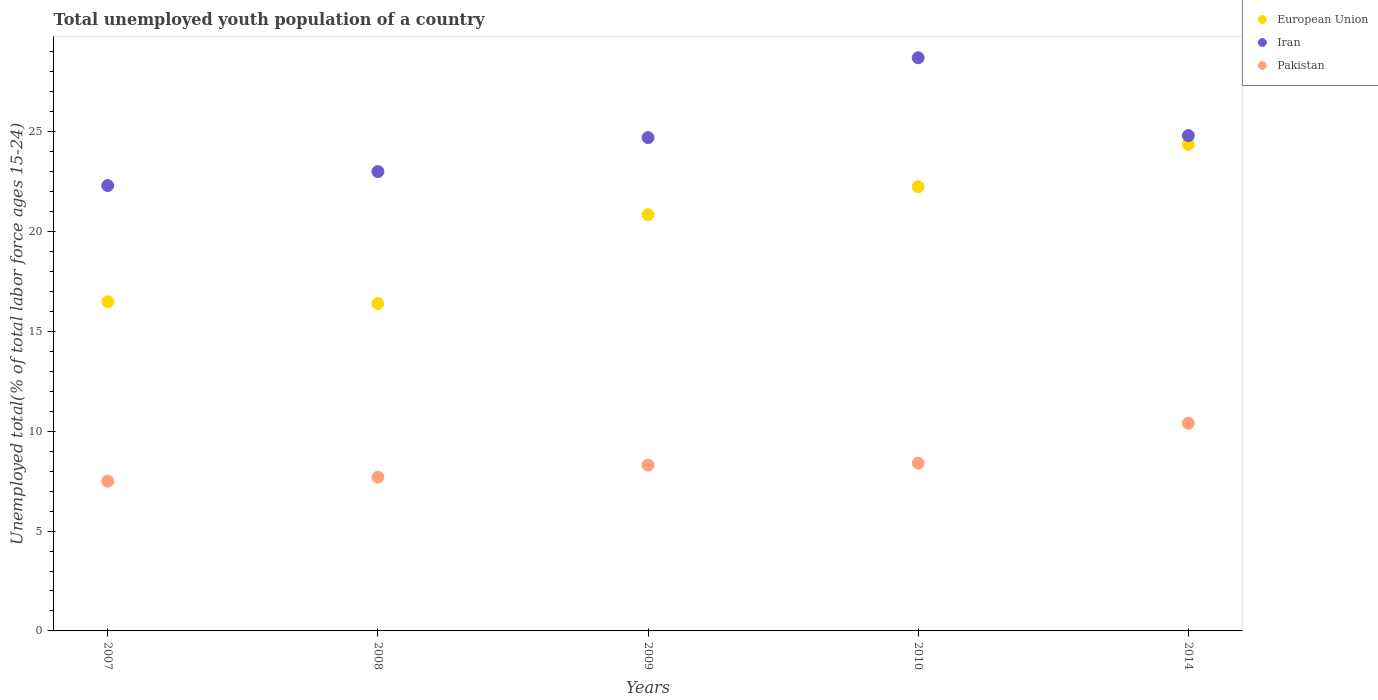How many different coloured dotlines are there?
Your answer should be compact. 3. Is the number of dotlines equal to the number of legend labels?
Your response must be concise. Yes. What is the percentage of total unemployed youth population of a country in European Union in 2009?
Offer a very short reply. 20.84. Across all years, what is the maximum percentage of total unemployed youth population of a country in Pakistan?
Provide a short and direct response. 10.4. Across all years, what is the minimum percentage of total unemployed youth population of a country in Pakistan?
Your response must be concise. 7.5. In which year was the percentage of total unemployed youth population of a country in Iran minimum?
Your response must be concise. 2007. What is the total percentage of total unemployed youth population of a country in Pakistan in the graph?
Offer a terse response. 42.3. What is the difference between the percentage of total unemployed youth population of a country in Pakistan in 2007 and that in 2010?
Give a very brief answer. -0.9. What is the difference between the percentage of total unemployed youth population of a country in European Union in 2008 and the percentage of total unemployed youth population of a country in Pakistan in 2007?
Provide a short and direct response. 8.89. What is the average percentage of total unemployed youth population of a country in European Union per year?
Ensure brevity in your answer.  20.06. In the year 2014, what is the difference between the percentage of total unemployed youth population of a country in European Union and percentage of total unemployed youth population of a country in Pakistan?
Give a very brief answer. 13.96. In how many years, is the percentage of total unemployed youth population of a country in Pakistan greater than 6 %?
Provide a succinct answer. 5. What is the ratio of the percentage of total unemployed youth population of a country in Iran in 2009 to that in 2014?
Your answer should be compact. 1. Is the difference between the percentage of total unemployed youth population of a country in European Union in 2007 and 2009 greater than the difference between the percentage of total unemployed youth population of a country in Pakistan in 2007 and 2009?
Your response must be concise. No. What is the difference between the highest and the second highest percentage of total unemployed youth population of a country in European Union?
Your answer should be compact. 2.12. What is the difference between the highest and the lowest percentage of total unemployed youth population of a country in European Union?
Provide a short and direct response. 7.97. In how many years, is the percentage of total unemployed youth population of a country in European Union greater than the average percentage of total unemployed youth population of a country in European Union taken over all years?
Ensure brevity in your answer.  3. Is it the case that in every year, the sum of the percentage of total unemployed youth population of a country in Iran and percentage of total unemployed youth population of a country in Pakistan  is greater than the percentage of total unemployed youth population of a country in European Union?
Give a very brief answer. Yes. Is the percentage of total unemployed youth population of a country in Iran strictly greater than the percentage of total unemployed youth population of a country in European Union over the years?
Your response must be concise. Yes. Is the percentage of total unemployed youth population of a country in European Union strictly less than the percentage of total unemployed youth population of a country in Iran over the years?
Your response must be concise. Yes. How many dotlines are there?
Offer a terse response. 3. How many years are there in the graph?
Give a very brief answer. 5. Are the values on the major ticks of Y-axis written in scientific E-notation?
Your answer should be very brief. No. How many legend labels are there?
Offer a very short reply. 3. How are the legend labels stacked?
Provide a succinct answer. Vertical. What is the title of the graph?
Your answer should be compact. Total unemployed youth population of a country. What is the label or title of the Y-axis?
Keep it short and to the point. Unemployed total(% of total labor force ages 15-24). What is the Unemployed total(% of total labor force ages 15-24) of European Union in 2007?
Make the answer very short. 16.49. What is the Unemployed total(% of total labor force ages 15-24) in Iran in 2007?
Make the answer very short. 22.3. What is the Unemployed total(% of total labor force ages 15-24) in Pakistan in 2007?
Your answer should be compact. 7.5. What is the Unemployed total(% of total labor force ages 15-24) in European Union in 2008?
Make the answer very short. 16.39. What is the Unemployed total(% of total labor force ages 15-24) of Pakistan in 2008?
Provide a short and direct response. 7.7. What is the Unemployed total(% of total labor force ages 15-24) in European Union in 2009?
Give a very brief answer. 20.84. What is the Unemployed total(% of total labor force ages 15-24) in Iran in 2009?
Make the answer very short. 24.7. What is the Unemployed total(% of total labor force ages 15-24) of Pakistan in 2009?
Your answer should be very brief. 8.3. What is the Unemployed total(% of total labor force ages 15-24) of European Union in 2010?
Provide a short and direct response. 22.24. What is the Unemployed total(% of total labor force ages 15-24) in Iran in 2010?
Your answer should be very brief. 28.7. What is the Unemployed total(% of total labor force ages 15-24) of Pakistan in 2010?
Provide a succinct answer. 8.4. What is the Unemployed total(% of total labor force ages 15-24) of European Union in 2014?
Offer a very short reply. 24.36. What is the Unemployed total(% of total labor force ages 15-24) in Iran in 2014?
Provide a short and direct response. 24.8. What is the Unemployed total(% of total labor force ages 15-24) in Pakistan in 2014?
Give a very brief answer. 10.4. Across all years, what is the maximum Unemployed total(% of total labor force ages 15-24) of European Union?
Your answer should be very brief. 24.36. Across all years, what is the maximum Unemployed total(% of total labor force ages 15-24) in Iran?
Provide a succinct answer. 28.7. Across all years, what is the maximum Unemployed total(% of total labor force ages 15-24) of Pakistan?
Offer a terse response. 10.4. Across all years, what is the minimum Unemployed total(% of total labor force ages 15-24) in European Union?
Give a very brief answer. 16.39. Across all years, what is the minimum Unemployed total(% of total labor force ages 15-24) in Iran?
Ensure brevity in your answer.  22.3. What is the total Unemployed total(% of total labor force ages 15-24) in European Union in the graph?
Offer a terse response. 100.32. What is the total Unemployed total(% of total labor force ages 15-24) in Iran in the graph?
Offer a very short reply. 123.5. What is the total Unemployed total(% of total labor force ages 15-24) of Pakistan in the graph?
Offer a very short reply. 42.3. What is the difference between the Unemployed total(% of total labor force ages 15-24) of European Union in 2007 and that in 2008?
Offer a terse response. 0.1. What is the difference between the Unemployed total(% of total labor force ages 15-24) of Iran in 2007 and that in 2008?
Offer a terse response. -0.7. What is the difference between the Unemployed total(% of total labor force ages 15-24) in European Union in 2007 and that in 2009?
Keep it short and to the point. -4.35. What is the difference between the Unemployed total(% of total labor force ages 15-24) in Iran in 2007 and that in 2009?
Offer a terse response. -2.4. What is the difference between the Unemployed total(% of total labor force ages 15-24) of Pakistan in 2007 and that in 2009?
Provide a succinct answer. -0.8. What is the difference between the Unemployed total(% of total labor force ages 15-24) in European Union in 2007 and that in 2010?
Make the answer very short. -5.75. What is the difference between the Unemployed total(% of total labor force ages 15-24) of Iran in 2007 and that in 2010?
Offer a terse response. -6.4. What is the difference between the Unemployed total(% of total labor force ages 15-24) in European Union in 2007 and that in 2014?
Give a very brief answer. -7.88. What is the difference between the Unemployed total(% of total labor force ages 15-24) in Iran in 2007 and that in 2014?
Keep it short and to the point. -2.5. What is the difference between the Unemployed total(% of total labor force ages 15-24) in Pakistan in 2007 and that in 2014?
Your answer should be very brief. -2.9. What is the difference between the Unemployed total(% of total labor force ages 15-24) in European Union in 2008 and that in 2009?
Provide a short and direct response. -4.45. What is the difference between the Unemployed total(% of total labor force ages 15-24) of Iran in 2008 and that in 2009?
Ensure brevity in your answer.  -1.7. What is the difference between the Unemployed total(% of total labor force ages 15-24) in European Union in 2008 and that in 2010?
Offer a terse response. -5.85. What is the difference between the Unemployed total(% of total labor force ages 15-24) of Pakistan in 2008 and that in 2010?
Ensure brevity in your answer.  -0.7. What is the difference between the Unemployed total(% of total labor force ages 15-24) in European Union in 2008 and that in 2014?
Provide a short and direct response. -7.97. What is the difference between the Unemployed total(% of total labor force ages 15-24) of European Union in 2009 and that in 2010?
Give a very brief answer. -1.4. What is the difference between the Unemployed total(% of total labor force ages 15-24) of Pakistan in 2009 and that in 2010?
Keep it short and to the point. -0.1. What is the difference between the Unemployed total(% of total labor force ages 15-24) in European Union in 2009 and that in 2014?
Provide a short and direct response. -3.52. What is the difference between the Unemployed total(% of total labor force ages 15-24) of Iran in 2009 and that in 2014?
Offer a terse response. -0.1. What is the difference between the Unemployed total(% of total labor force ages 15-24) in European Union in 2010 and that in 2014?
Ensure brevity in your answer.  -2.12. What is the difference between the Unemployed total(% of total labor force ages 15-24) in Pakistan in 2010 and that in 2014?
Give a very brief answer. -2. What is the difference between the Unemployed total(% of total labor force ages 15-24) in European Union in 2007 and the Unemployed total(% of total labor force ages 15-24) in Iran in 2008?
Keep it short and to the point. -6.51. What is the difference between the Unemployed total(% of total labor force ages 15-24) of European Union in 2007 and the Unemployed total(% of total labor force ages 15-24) of Pakistan in 2008?
Provide a succinct answer. 8.79. What is the difference between the Unemployed total(% of total labor force ages 15-24) in Iran in 2007 and the Unemployed total(% of total labor force ages 15-24) in Pakistan in 2008?
Your response must be concise. 14.6. What is the difference between the Unemployed total(% of total labor force ages 15-24) of European Union in 2007 and the Unemployed total(% of total labor force ages 15-24) of Iran in 2009?
Make the answer very short. -8.21. What is the difference between the Unemployed total(% of total labor force ages 15-24) of European Union in 2007 and the Unemployed total(% of total labor force ages 15-24) of Pakistan in 2009?
Provide a succinct answer. 8.19. What is the difference between the Unemployed total(% of total labor force ages 15-24) in Iran in 2007 and the Unemployed total(% of total labor force ages 15-24) in Pakistan in 2009?
Provide a succinct answer. 14. What is the difference between the Unemployed total(% of total labor force ages 15-24) in European Union in 2007 and the Unemployed total(% of total labor force ages 15-24) in Iran in 2010?
Your answer should be very brief. -12.21. What is the difference between the Unemployed total(% of total labor force ages 15-24) in European Union in 2007 and the Unemployed total(% of total labor force ages 15-24) in Pakistan in 2010?
Ensure brevity in your answer.  8.09. What is the difference between the Unemployed total(% of total labor force ages 15-24) of Iran in 2007 and the Unemployed total(% of total labor force ages 15-24) of Pakistan in 2010?
Provide a succinct answer. 13.9. What is the difference between the Unemployed total(% of total labor force ages 15-24) of European Union in 2007 and the Unemployed total(% of total labor force ages 15-24) of Iran in 2014?
Offer a very short reply. -8.31. What is the difference between the Unemployed total(% of total labor force ages 15-24) in European Union in 2007 and the Unemployed total(% of total labor force ages 15-24) in Pakistan in 2014?
Ensure brevity in your answer.  6.09. What is the difference between the Unemployed total(% of total labor force ages 15-24) of European Union in 2008 and the Unemployed total(% of total labor force ages 15-24) of Iran in 2009?
Provide a short and direct response. -8.31. What is the difference between the Unemployed total(% of total labor force ages 15-24) of European Union in 2008 and the Unemployed total(% of total labor force ages 15-24) of Pakistan in 2009?
Your answer should be compact. 8.09. What is the difference between the Unemployed total(% of total labor force ages 15-24) of European Union in 2008 and the Unemployed total(% of total labor force ages 15-24) of Iran in 2010?
Your response must be concise. -12.31. What is the difference between the Unemployed total(% of total labor force ages 15-24) in European Union in 2008 and the Unemployed total(% of total labor force ages 15-24) in Pakistan in 2010?
Provide a short and direct response. 7.99. What is the difference between the Unemployed total(% of total labor force ages 15-24) of European Union in 2008 and the Unemployed total(% of total labor force ages 15-24) of Iran in 2014?
Your response must be concise. -8.41. What is the difference between the Unemployed total(% of total labor force ages 15-24) of European Union in 2008 and the Unemployed total(% of total labor force ages 15-24) of Pakistan in 2014?
Provide a short and direct response. 5.99. What is the difference between the Unemployed total(% of total labor force ages 15-24) in European Union in 2009 and the Unemployed total(% of total labor force ages 15-24) in Iran in 2010?
Provide a short and direct response. -7.86. What is the difference between the Unemployed total(% of total labor force ages 15-24) of European Union in 2009 and the Unemployed total(% of total labor force ages 15-24) of Pakistan in 2010?
Your answer should be compact. 12.44. What is the difference between the Unemployed total(% of total labor force ages 15-24) in European Union in 2009 and the Unemployed total(% of total labor force ages 15-24) in Iran in 2014?
Ensure brevity in your answer.  -3.96. What is the difference between the Unemployed total(% of total labor force ages 15-24) in European Union in 2009 and the Unemployed total(% of total labor force ages 15-24) in Pakistan in 2014?
Ensure brevity in your answer.  10.44. What is the difference between the Unemployed total(% of total labor force ages 15-24) of European Union in 2010 and the Unemployed total(% of total labor force ages 15-24) of Iran in 2014?
Keep it short and to the point. -2.56. What is the difference between the Unemployed total(% of total labor force ages 15-24) in European Union in 2010 and the Unemployed total(% of total labor force ages 15-24) in Pakistan in 2014?
Keep it short and to the point. 11.84. What is the average Unemployed total(% of total labor force ages 15-24) in European Union per year?
Provide a succinct answer. 20.06. What is the average Unemployed total(% of total labor force ages 15-24) in Iran per year?
Your answer should be very brief. 24.7. What is the average Unemployed total(% of total labor force ages 15-24) in Pakistan per year?
Provide a short and direct response. 8.46. In the year 2007, what is the difference between the Unemployed total(% of total labor force ages 15-24) of European Union and Unemployed total(% of total labor force ages 15-24) of Iran?
Offer a terse response. -5.81. In the year 2007, what is the difference between the Unemployed total(% of total labor force ages 15-24) in European Union and Unemployed total(% of total labor force ages 15-24) in Pakistan?
Make the answer very short. 8.99. In the year 2007, what is the difference between the Unemployed total(% of total labor force ages 15-24) of Iran and Unemployed total(% of total labor force ages 15-24) of Pakistan?
Your response must be concise. 14.8. In the year 2008, what is the difference between the Unemployed total(% of total labor force ages 15-24) in European Union and Unemployed total(% of total labor force ages 15-24) in Iran?
Make the answer very short. -6.61. In the year 2008, what is the difference between the Unemployed total(% of total labor force ages 15-24) in European Union and Unemployed total(% of total labor force ages 15-24) in Pakistan?
Your response must be concise. 8.69. In the year 2008, what is the difference between the Unemployed total(% of total labor force ages 15-24) in Iran and Unemployed total(% of total labor force ages 15-24) in Pakistan?
Your answer should be compact. 15.3. In the year 2009, what is the difference between the Unemployed total(% of total labor force ages 15-24) in European Union and Unemployed total(% of total labor force ages 15-24) in Iran?
Provide a short and direct response. -3.86. In the year 2009, what is the difference between the Unemployed total(% of total labor force ages 15-24) in European Union and Unemployed total(% of total labor force ages 15-24) in Pakistan?
Ensure brevity in your answer.  12.54. In the year 2009, what is the difference between the Unemployed total(% of total labor force ages 15-24) in Iran and Unemployed total(% of total labor force ages 15-24) in Pakistan?
Ensure brevity in your answer.  16.4. In the year 2010, what is the difference between the Unemployed total(% of total labor force ages 15-24) in European Union and Unemployed total(% of total labor force ages 15-24) in Iran?
Offer a terse response. -6.46. In the year 2010, what is the difference between the Unemployed total(% of total labor force ages 15-24) in European Union and Unemployed total(% of total labor force ages 15-24) in Pakistan?
Give a very brief answer. 13.84. In the year 2010, what is the difference between the Unemployed total(% of total labor force ages 15-24) in Iran and Unemployed total(% of total labor force ages 15-24) in Pakistan?
Provide a succinct answer. 20.3. In the year 2014, what is the difference between the Unemployed total(% of total labor force ages 15-24) in European Union and Unemployed total(% of total labor force ages 15-24) in Iran?
Make the answer very short. -0.44. In the year 2014, what is the difference between the Unemployed total(% of total labor force ages 15-24) in European Union and Unemployed total(% of total labor force ages 15-24) in Pakistan?
Provide a short and direct response. 13.96. In the year 2014, what is the difference between the Unemployed total(% of total labor force ages 15-24) in Iran and Unemployed total(% of total labor force ages 15-24) in Pakistan?
Your answer should be compact. 14.4. What is the ratio of the Unemployed total(% of total labor force ages 15-24) in Iran in 2007 to that in 2008?
Your answer should be very brief. 0.97. What is the ratio of the Unemployed total(% of total labor force ages 15-24) in Pakistan in 2007 to that in 2008?
Provide a short and direct response. 0.97. What is the ratio of the Unemployed total(% of total labor force ages 15-24) in European Union in 2007 to that in 2009?
Provide a succinct answer. 0.79. What is the ratio of the Unemployed total(% of total labor force ages 15-24) of Iran in 2007 to that in 2009?
Ensure brevity in your answer.  0.9. What is the ratio of the Unemployed total(% of total labor force ages 15-24) of Pakistan in 2007 to that in 2009?
Your answer should be compact. 0.9. What is the ratio of the Unemployed total(% of total labor force ages 15-24) in European Union in 2007 to that in 2010?
Keep it short and to the point. 0.74. What is the ratio of the Unemployed total(% of total labor force ages 15-24) of Iran in 2007 to that in 2010?
Give a very brief answer. 0.78. What is the ratio of the Unemployed total(% of total labor force ages 15-24) of Pakistan in 2007 to that in 2010?
Provide a succinct answer. 0.89. What is the ratio of the Unemployed total(% of total labor force ages 15-24) of European Union in 2007 to that in 2014?
Give a very brief answer. 0.68. What is the ratio of the Unemployed total(% of total labor force ages 15-24) of Iran in 2007 to that in 2014?
Offer a very short reply. 0.9. What is the ratio of the Unemployed total(% of total labor force ages 15-24) in Pakistan in 2007 to that in 2014?
Your response must be concise. 0.72. What is the ratio of the Unemployed total(% of total labor force ages 15-24) in European Union in 2008 to that in 2009?
Keep it short and to the point. 0.79. What is the ratio of the Unemployed total(% of total labor force ages 15-24) of Iran in 2008 to that in 2009?
Keep it short and to the point. 0.93. What is the ratio of the Unemployed total(% of total labor force ages 15-24) in Pakistan in 2008 to that in 2009?
Keep it short and to the point. 0.93. What is the ratio of the Unemployed total(% of total labor force ages 15-24) in European Union in 2008 to that in 2010?
Offer a terse response. 0.74. What is the ratio of the Unemployed total(% of total labor force ages 15-24) of Iran in 2008 to that in 2010?
Make the answer very short. 0.8. What is the ratio of the Unemployed total(% of total labor force ages 15-24) in Pakistan in 2008 to that in 2010?
Ensure brevity in your answer.  0.92. What is the ratio of the Unemployed total(% of total labor force ages 15-24) of European Union in 2008 to that in 2014?
Offer a very short reply. 0.67. What is the ratio of the Unemployed total(% of total labor force ages 15-24) in Iran in 2008 to that in 2014?
Offer a very short reply. 0.93. What is the ratio of the Unemployed total(% of total labor force ages 15-24) in Pakistan in 2008 to that in 2014?
Provide a short and direct response. 0.74. What is the ratio of the Unemployed total(% of total labor force ages 15-24) in European Union in 2009 to that in 2010?
Your response must be concise. 0.94. What is the ratio of the Unemployed total(% of total labor force ages 15-24) of Iran in 2009 to that in 2010?
Provide a succinct answer. 0.86. What is the ratio of the Unemployed total(% of total labor force ages 15-24) in European Union in 2009 to that in 2014?
Keep it short and to the point. 0.86. What is the ratio of the Unemployed total(% of total labor force ages 15-24) of Pakistan in 2009 to that in 2014?
Your answer should be very brief. 0.8. What is the ratio of the Unemployed total(% of total labor force ages 15-24) of European Union in 2010 to that in 2014?
Your answer should be compact. 0.91. What is the ratio of the Unemployed total(% of total labor force ages 15-24) of Iran in 2010 to that in 2014?
Make the answer very short. 1.16. What is the ratio of the Unemployed total(% of total labor force ages 15-24) of Pakistan in 2010 to that in 2014?
Offer a very short reply. 0.81. What is the difference between the highest and the second highest Unemployed total(% of total labor force ages 15-24) in European Union?
Keep it short and to the point. 2.12. What is the difference between the highest and the second highest Unemployed total(% of total labor force ages 15-24) of Iran?
Your answer should be compact. 3.9. What is the difference between the highest and the second highest Unemployed total(% of total labor force ages 15-24) of Pakistan?
Keep it short and to the point. 2. What is the difference between the highest and the lowest Unemployed total(% of total labor force ages 15-24) of European Union?
Give a very brief answer. 7.97. 